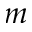<formula> <loc_0><loc_0><loc_500><loc_500>m</formula> 